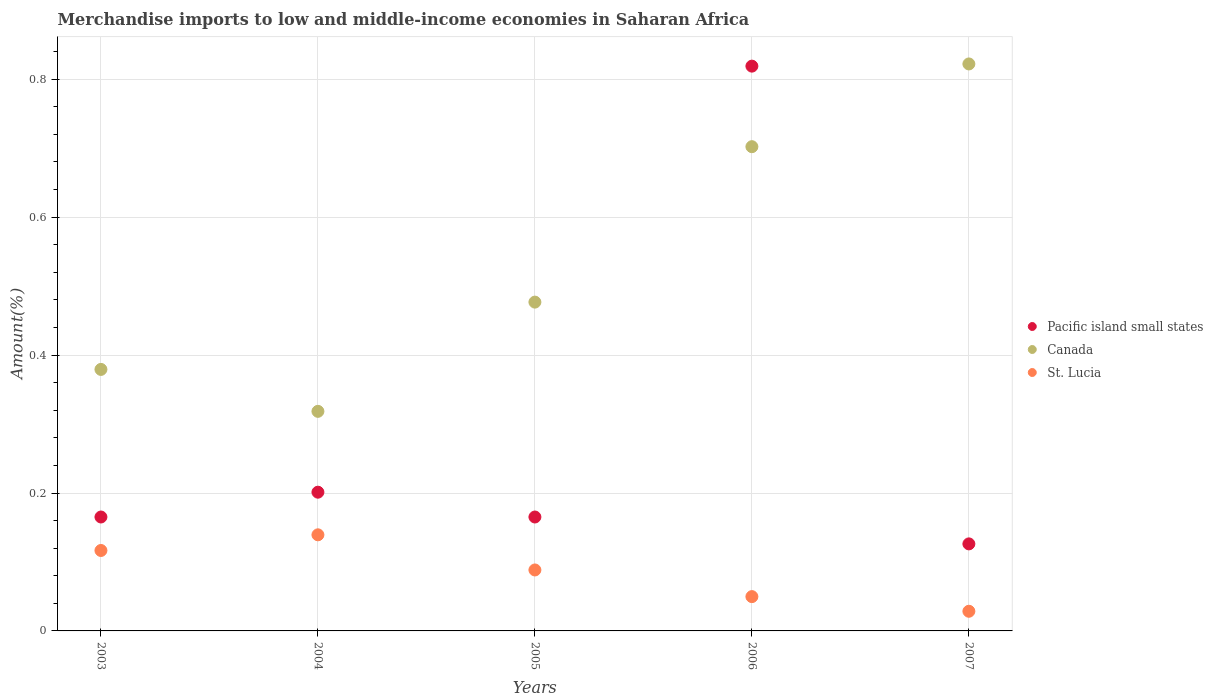What is the percentage of amount earned from merchandise imports in St. Lucia in 2007?
Provide a short and direct response. 0.03. Across all years, what is the maximum percentage of amount earned from merchandise imports in Canada?
Offer a very short reply. 0.82. Across all years, what is the minimum percentage of amount earned from merchandise imports in Pacific island small states?
Provide a short and direct response. 0.13. In which year was the percentage of amount earned from merchandise imports in St. Lucia maximum?
Your response must be concise. 2004. What is the total percentage of amount earned from merchandise imports in St. Lucia in the graph?
Provide a short and direct response. 0.42. What is the difference between the percentage of amount earned from merchandise imports in St. Lucia in 2004 and that in 2006?
Your answer should be compact. 0.09. What is the difference between the percentage of amount earned from merchandise imports in Canada in 2006 and the percentage of amount earned from merchandise imports in Pacific island small states in 2004?
Ensure brevity in your answer.  0.5. What is the average percentage of amount earned from merchandise imports in Canada per year?
Your answer should be compact. 0.54. In the year 2004, what is the difference between the percentage of amount earned from merchandise imports in St. Lucia and percentage of amount earned from merchandise imports in Pacific island small states?
Ensure brevity in your answer.  -0.06. What is the ratio of the percentage of amount earned from merchandise imports in Pacific island small states in 2006 to that in 2007?
Ensure brevity in your answer.  6.49. Is the percentage of amount earned from merchandise imports in St. Lucia in 2004 less than that in 2005?
Your answer should be compact. No. What is the difference between the highest and the second highest percentage of amount earned from merchandise imports in Pacific island small states?
Provide a succinct answer. 0.62. What is the difference between the highest and the lowest percentage of amount earned from merchandise imports in Canada?
Provide a succinct answer. 0.5. In how many years, is the percentage of amount earned from merchandise imports in Pacific island small states greater than the average percentage of amount earned from merchandise imports in Pacific island small states taken over all years?
Provide a short and direct response. 1. Is the sum of the percentage of amount earned from merchandise imports in Pacific island small states in 2003 and 2004 greater than the maximum percentage of amount earned from merchandise imports in St. Lucia across all years?
Offer a terse response. Yes. Is it the case that in every year, the sum of the percentage of amount earned from merchandise imports in Pacific island small states and percentage of amount earned from merchandise imports in Canada  is greater than the percentage of amount earned from merchandise imports in St. Lucia?
Give a very brief answer. Yes. Does the percentage of amount earned from merchandise imports in St. Lucia monotonically increase over the years?
Give a very brief answer. No. Is the percentage of amount earned from merchandise imports in Pacific island small states strictly greater than the percentage of amount earned from merchandise imports in St. Lucia over the years?
Your answer should be compact. Yes. How many years are there in the graph?
Ensure brevity in your answer.  5. What is the difference between two consecutive major ticks on the Y-axis?
Your answer should be very brief. 0.2. Are the values on the major ticks of Y-axis written in scientific E-notation?
Provide a succinct answer. No. Does the graph contain any zero values?
Your response must be concise. No. Does the graph contain grids?
Keep it short and to the point. Yes. Where does the legend appear in the graph?
Give a very brief answer. Center right. What is the title of the graph?
Ensure brevity in your answer.  Merchandise imports to low and middle-income economies in Saharan Africa. Does "Uruguay" appear as one of the legend labels in the graph?
Offer a very short reply. No. What is the label or title of the Y-axis?
Keep it short and to the point. Amount(%). What is the Amount(%) of Pacific island small states in 2003?
Your answer should be compact. 0.17. What is the Amount(%) in Canada in 2003?
Keep it short and to the point. 0.38. What is the Amount(%) of St. Lucia in 2003?
Provide a succinct answer. 0.12. What is the Amount(%) of Pacific island small states in 2004?
Make the answer very short. 0.2. What is the Amount(%) of Canada in 2004?
Your answer should be compact. 0.32. What is the Amount(%) in St. Lucia in 2004?
Provide a succinct answer. 0.14. What is the Amount(%) in Pacific island small states in 2005?
Offer a terse response. 0.17. What is the Amount(%) of Canada in 2005?
Your answer should be compact. 0.48. What is the Amount(%) in St. Lucia in 2005?
Your answer should be very brief. 0.09. What is the Amount(%) of Pacific island small states in 2006?
Give a very brief answer. 0.82. What is the Amount(%) of Canada in 2006?
Offer a very short reply. 0.7. What is the Amount(%) of St. Lucia in 2006?
Provide a succinct answer. 0.05. What is the Amount(%) of Pacific island small states in 2007?
Make the answer very short. 0.13. What is the Amount(%) of Canada in 2007?
Offer a terse response. 0.82. What is the Amount(%) of St. Lucia in 2007?
Your response must be concise. 0.03. Across all years, what is the maximum Amount(%) in Pacific island small states?
Your answer should be compact. 0.82. Across all years, what is the maximum Amount(%) of Canada?
Offer a very short reply. 0.82. Across all years, what is the maximum Amount(%) in St. Lucia?
Keep it short and to the point. 0.14. Across all years, what is the minimum Amount(%) in Pacific island small states?
Offer a terse response. 0.13. Across all years, what is the minimum Amount(%) of Canada?
Ensure brevity in your answer.  0.32. Across all years, what is the minimum Amount(%) of St. Lucia?
Provide a short and direct response. 0.03. What is the total Amount(%) of Pacific island small states in the graph?
Give a very brief answer. 1.48. What is the total Amount(%) of Canada in the graph?
Your answer should be compact. 2.7. What is the total Amount(%) of St. Lucia in the graph?
Your answer should be compact. 0.42. What is the difference between the Amount(%) in Pacific island small states in 2003 and that in 2004?
Provide a succinct answer. -0.04. What is the difference between the Amount(%) of Canada in 2003 and that in 2004?
Your response must be concise. 0.06. What is the difference between the Amount(%) in St. Lucia in 2003 and that in 2004?
Provide a short and direct response. -0.02. What is the difference between the Amount(%) of Pacific island small states in 2003 and that in 2005?
Keep it short and to the point. 0. What is the difference between the Amount(%) in Canada in 2003 and that in 2005?
Ensure brevity in your answer.  -0.1. What is the difference between the Amount(%) of St. Lucia in 2003 and that in 2005?
Ensure brevity in your answer.  0.03. What is the difference between the Amount(%) in Pacific island small states in 2003 and that in 2006?
Ensure brevity in your answer.  -0.65. What is the difference between the Amount(%) in Canada in 2003 and that in 2006?
Offer a very short reply. -0.32. What is the difference between the Amount(%) in St. Lucia in 2003 and that in 2006?
Your response must be concise. 0.07. What is the difference between the Amount(%) in Pacific island small states in 2003 and that in 2007?
Give a very brief answer. 0.04. What is the difference between the Amount(%) of Canada in 2003 and that in 2007?
Make the answer very short. -0.44. What is the difference between the Amount(%) in St. Lucia in 2003 and that in 2007?
Offer a very short reply. 0.09. What is the difference between the Amount(%) of Pacific island small states in 2004 and that in 2005?
Your response must be concise. 0.04. What is the difference between the Amount(%) in Canada in 2004 and that in 2005?
Your answer should be very brief. -0.16. What is the difference between the Amount(%) of St. Lucia in 2004 and that in 2005?
Provide a short and direct response. 0.05. What is the difference between the Amount(%) in Pacific island small states in 2004 and that in 2006?
Ensure brevity in your answer.  -0.62. What is the difference between the Amount(%) of Canada in 2004 and that in 2006?
Your response must be concise. -0.38. What is the difference between the Amount(%) of St. Lucia in 2004 and that in 2006?
Your response must be concise. 0.09. What is the difference between the Amount(%) of Pacific island small states in 2004 and that in 2007?
Ensure brevity in your answer.  0.07. What is the difference between the Amount(%) of Canada in 2004 and that in 2007?
Provide a succinct answer. -0.5. What is the difference between the Amount(%) of St. Lucia in 2004 and that in 2007?
Provide a succinct answer. 0.11. What is the difference between the Amount(%) in Pacific island small states in 2005 and that in 2006?
Keep it short and to the point. -0.65. What is the difference between the Amount(%) in Canada in 2005 and that in 2006?
Your answer should be very brief. -0.23. What is the difference between the Amount(%) in St. Lucia in 2005 and that in 2006?
Ensure brevity in your answer.  0.04. What is the difference between the Amount(%) of Pacific island small states in 2005 and that in 2007?
Ensure brevity in your answer.  0.04. What is the difference between the Amount(%) of Canada in 2005 and that in 2007?
Provide a succinct answer. -0.35. What is the difference between the Amount(%) in St. Lucia in 2005 and that in 2007?
Provide a succinct answer. 0.06. What is the difference between the Amount(%) in Pacific island small states in 2006 and that in 2007?
Offer a very short reply. 0.69. What is the difference between the Amount(%) in Canada in 2006 and that in 2007?
Ensure brevity in your answer.  -0.12. What is the difference between the Amount(%) of St. Lucia in 2006 and that in 2007?
Ensure brevity in your answer.  0.02. What is the difference between the Amount(%) of Pacific island small states in 2003 and the Amount(%) of Canada in 2004?
Your response must be concise. -0.15. What is the difference between the Amount(%) of Pacific island small states in 2003 and the Amount(%) of St. Lucia in 2004?
Your answer should be compact. 0.03. What is the difference between the Amount(%) in Canada in 2003 and the Amount(%) in St. Lucia in 2004?
Make the answer very short. 0.24. What is the difference between the Amount(%) of Pacific island small states in 2003 and the Amount(%) of Canada in 2005?
Provide a succinct answer. -0.31. What is the difference between the Amount(%) of Pacific island small states in 2003 and the Amount(%) of St. Lucia in 2005?
Make the answer very short. 0.08. What is the difference between the Amount(%) in Canada in 2003 and the Amount(%) in St. Lucia in 2005?
Offer a terse response. 0.29. What is the difference between the Amount(%) in Pacific island small states in 2003 and the Amount(%) in Canada in 2006?
Ensure brevity in your answer.  -0.54. What is the difference between the Amount(%) of Pacific island small states in 2003 and the Amount(%) of St. Lucia in 2006?
Make the answer very short. 0.12. What is the difference between the Amount(%) in Canada in 2003 and the Amount(%) in St. Lucia in 2006?
Your answer should be compact. 0.33. What is the difference between the Amount(%) in Pacific island small states in 2003 and the Amount(%) in Canada in 2007?
Your response must be concise. -0.66. What is the difference between the Amount(%) in Pacific island small states in 2003 and the Amount(%) in St. Lucia in 2007?
Your answer should be very brief. 0.14. What is the difference between the Amount(%) in Canada in 2003 and the Amount(%) in St. Lucia in 2007?
Your answer should be very brief. 0.35. What is the difference between the Amount(%) of Pacific island small states in 2004 and the Amount(%) of Canada in 2005?
Ensure brevity in your answer.  -0.28. What is the difference between the Amount(%) in Pacific island small states in 2004 and the Amount(%) in St. Lucia in 2005?
Give a very brief answer. 0.11. What is the difference between the Amount(%) in Canada in 2004 and the Amount(%) in St. Lucia in 2005?
Make the answer very short. 0.23. What is the difference between the Amount(%) of Pacific island small states in 2004 and the Amount(%) of Canada in 2006?
Ensure brevity in your answer.  -0.5. What is the difference between the Amount(%) in Pacific island small states in 2004 and the Amount(%) in St. Lucia in 2006?
Provide a short and direct response. 0.15. What is the difference between the Amount(%) in Canada in 2004 and the Amount(%) in St. Lucia in 2006?
Offer a very short reply. 0.27. What is the difference between the Amount(%) of Pacific island small states in 2004 and the Amount(%) of Canada in 2007?
Your answer should be very brief. -0.62. What is the difference between the Amount(%) of Pacific island small states in 2004 and the Amount(%) of St. Lucia in 2007?
Offer a very short reply. 0.17. What is the difference between the Amount(%) in Canada in 2004 and the Amount(%) in St. Lucia in 2007?
Offer a very short reply. 0.29. What is the difference between the Amount(%) of Pacific island small states in 2005 and the Amount(%) of Canada in 2006?
Make the answer very short. -0.54. What is the difference between the Amount(%) of Pacific island small states in 2005 and the Amount(%) of St. Lucia in 2006?
Offer a very short reply. 0.12. What is the difference between the Amount(%) in Canada in 2005 and the Amount(%) in St. Lucia in 2006?
Give a very brief answer. 0.43. What is the difference between the Amount(%) of Pacific island small states in 2005 and the Amount(%) of Canada in 2007?
Your answer should be very brief. -0.66. What is the difference between the Amount(%) in Pacific island small states in 2005 and the Amount(%) in St. Lucia in 2007?
Keep it short and to the point. 0.14. What is the difference between the Amount(%) of Canada in 2005 and the Amount(%) of St. Lucia in 2007?
Provide a short and direct response. 0.45. What is the difference between the Amount(%) in Pacific island small states in 2006 and the Amount(%) in Canada in 2007?
Offer a very short reply. -0. What is the difference between the Amount(%) in Pacific island small states in 2006 and the Amount(%) in St. Lucia in 2007?
Your answer should be compact. 0.79. What is the difference between the Amount(%) in Canada in 2006 and the Amount(%) in St. Lucia in 2007?
Provide a succinct answer. 0.67. What is the average Amount(%) of Pacific island small states per year?
Make the answer very short. 0.3. What is the average Amount(%) of Canada per year?
Your answer should be very brief. 0.54. What is the average Amount(%) of St. Lucia per year?
Ensure brevity in your answer.  0.08. In the year 2003, what is the difference between the Amount(%) of Pacific island small states and Amount(%) of Canada?
Make the answer very short. -0.21. In the year 2003, what is the difference between the Amount(%) in Pacific island small states and Amount(%) in St. Lucia?
Keep it short and to the point. 0.05. In the year 2003, what is the difference between the Amount(%) in Canada and Amount(%) in St. Lucia?
Provide a succinct answer. 0.26. In the year 2004, what is the difference between the Amount(%) of Pacific island small states and Amount(%) of Canada?
Make the answer very short. -0.12. In the year 2004, what is the difference between the Amount(%) in Pacific island small states and Amount(%) in St. Lucia?
Provide a succinct answer. 0.06. In the year 2004, what is the difference between the Amount(%) in Canada and Amount(%) in St. Lucia?
Provide a succinct answer. 0.18. In the year 2005, what is the difference between the Amount(%) in Pacific island small states and Amount(%) in Canada?
Your response must be concise. -0.31. In the year 2005, what is the difference between the Amount(%) in Pacific island small states and Amount(%) in St. Lucia?
Give a very brief answer. 0.08. In the year 2005, what is the difference between the Amount(%) in Canada and Amount(%) in St. Lucia?
Offer a terse response. 0.39. In the year 2006, what is the difference between the Amount(%) in Pacific island small states and Amount(%) in Canada?
Offer a terse response. 0.12. In the year 2006, what is the difference between the Amount(%) of Pacific island small states and Amount(%) of St. Lucia?
Give a very brief answer. 0.77. In the year 2006, what is the difference between the Amount(%) of Canada and Amount(%) of St. Lucia?
Your answer should be compact. 0.65. In the year 2007, what is the difference between the Amount(%) in Pacific island small states and Amount(%) in Canada?
Offer a very short reply. -0.7. In the year 2007, what is the difference between the Amount(%) of Pacific island small states and Amount(%) of St. Lucia?
Your answer should be compact. 0.1. In the year 2007, what is the difference between the Amount(%) in Canada and Amount(%) in St. Lucia?
Offer a very short reply. 0.79. What is the ratio of the Amount(%) of Pacific island small states in 2003 to that in 2004?
Your answer should be compact. 0.82. What is the ratio of the Amount(%) in Canada in 2003 to that in 2004?
Provide a succinct answer. 1.19. What is the ratio of the Amount(%) of St. Lucia in 2003 to that in 2004?
Make the answer very short. 0.84. What is the ratio of the Amount(%) of Canada in 2003 to that in 2005?
Make the answer very short. 0.8. What is the ratio of the Amount(%) in St. Lucia in 2003 to that in 2005?
Offer a very short reply. 1.32. What is the ratio of the Amount(%) of Pacific island small states in 2003 to that in 2006?
Provide a short and direct response. 0.2. What is the ratio of the Amount(%) in Canada in 2003 to that in 2006?
Your answer should be very brief. 0.54. What is the ratio of the Amount(%) of St. Lucia in 2003 to that in 2006?
Offer a terse response. 2.34. What is the ratio of the Amount(%) of Pacific island small states in 2003 to that in 2007?
Provide a succinct answer. 1.31. What is the ratio of the Amount(%) in Canada in 2003 to that in 2007?
Provide a succinct answer. 0.46. What is the ratio of the Amount(%) in St. Lucia in 2003 to that in 2007?
Make the answer very short. 4.09. What is the ratio of the Amount(%) in Pacific island small states in 2004 to that in 2005?
Make the answer very short. 1.22. What is the ratio of the Amount(%) in Canada in 2004 to that in 2005?
Provide a succinct answer. 0.67. What is the ratio of the Amount(%) of St. Lucia in 2004 to that in 2005?
Offer a terse response. 1.58. What is the ratio of the Amount(%) in Pacific island small states in 2004 to that in 2006?
Ensure brevity in your answer.  0.25. What is the ratio of the Amount(%) in Canada in 2004 to that in 2006?
Offer a very short reply. 0.45. What is the ratio of the Amount(%) of St. Lucia in 2004 to that in 2006?
Offer a very short reply. 2.8. What is the ratio of the Amount(%) in Pacific island small states in 2004 to that in 2007?
Give a very brief answer. 1.59. What is the ratio of the Amount(%) in Canada in 2004 to that in 2007?
Your answer should be compact. 0.39. What is the ratio of the Amount(%) of St. Lucia in 2004 to that in 2007?
Keep it short and to the point. 4.89. What is the ratio of the Amount(%) of Pacific island small states in 2005 to that in 2006?
Keep it short and to the point. 0.2. What is the ratio of the Amount(%) in Canada in 2005 to that in 2006?
Provide a succinct answer. 0.68. What is the ratio of the Amount(%) in St. Lucia in 2005 to that in 2006?
Ensure brevity in your answer.  1.78. What is the ratio of the Amount(%) of Pacific island small states in 2005 to that in 2007?
Offer a terse response. 1.31. What is the ratio of the Amount(%) of Canada in 2005 to that in 2007?
Your answer should be very brief. 0.58. What is the ratio of the Amount(%) of St. Lucia in 2005 to that in 2007?
Give a very brief answer. 3.1. What is the ratio of the Amount(%) of Pacific island small states in 2006 to that in 2007?
Offer a terse response. 6.49. What is the ratio of the Amount(%) in Canada in 2006 to that in 2007?
Provide a short and direct response. 0.85. What is the ratio of the Amount(%) of St. Lucia in 2006 to that in 2007?
Your response must be concise. 1.75. What is the difference between the highest and the second highest Amount(%) in Pacific island small states?
Make the answer very short. 0.62. What is the difference between the highest and the second highest Amount(%) of Canada?
Your answer should be very brief. 0.12. What is the difference between the highest and the second highest Amount(%) in St. Lucia?
Ensure brevity in your answer.  0.02. What is the difference between the highest and the lowest Amount(%) in Pacific island small states?
Provide a short and direct response. 0.69. What is the difference between the highest and the lowest Amount(%) in Canada?
Make the answer very short. 0.5. What is the difference between the highest and the lowest Amount(%) of St. Lucia?
Give a very brief answer. 0.11. 